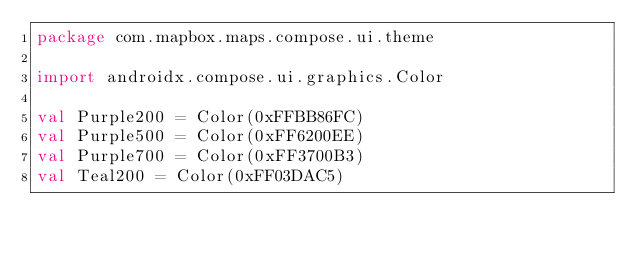<code> <loc_0><loc_0><loc_500><loc_500><_Kotlin_>package com.mapbox.maps.compose.ui.theme

import androidx.compose.ui.graphics.Color

val Purple200 = Color(0xFFBB86FC)
val Purple500 = Color(0xFF6200EE)
val Purple700 = Color(0xFF3700B3)
val Teal200 = Color(0xFF03DAC5)</code> 